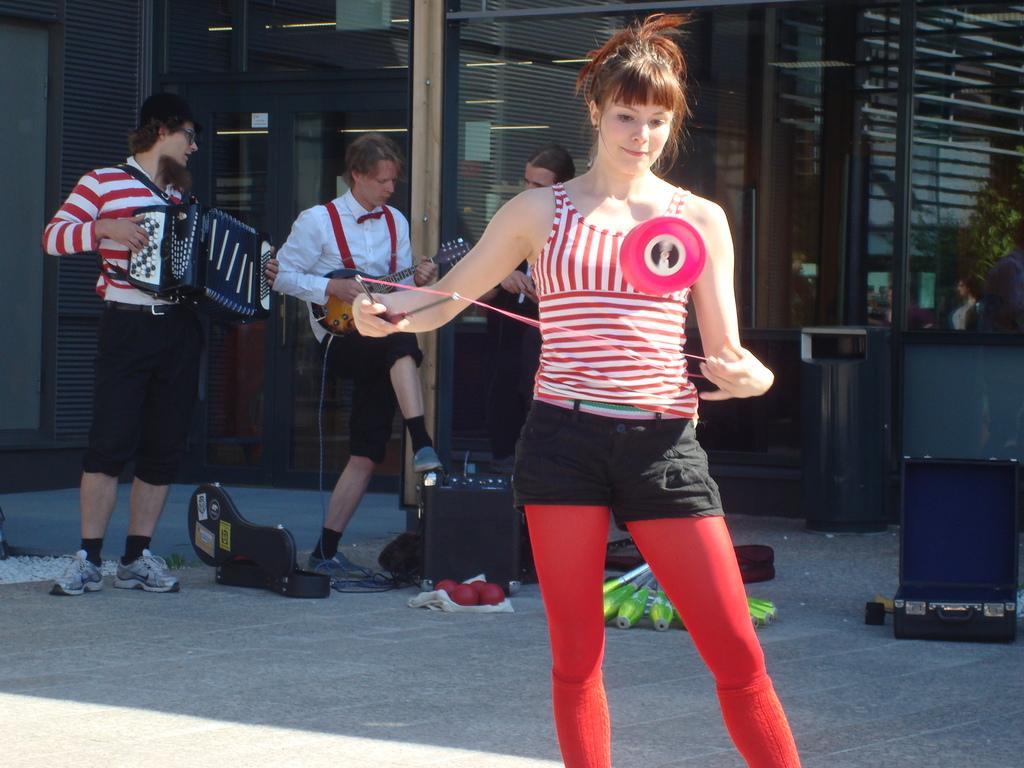How would you summarize this image in a sentence or two? There is a woman standing on the road performing an activity with the two sticks and a thread. In the background, there are men who are playing a different musical instruments and a speaker on the ground. 